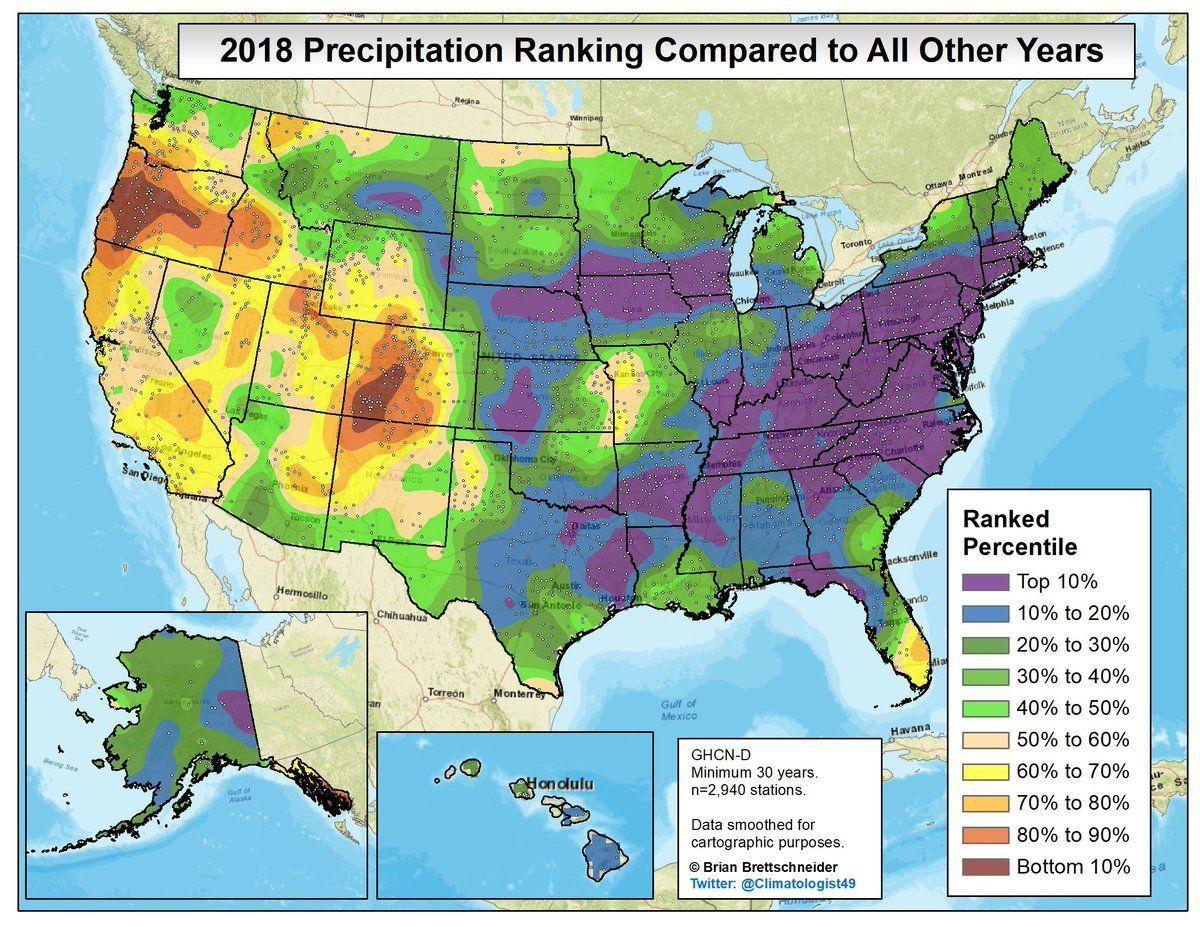Which color depict the bottom 10% precipitation ranking, red, orange or yellow?
Answer the question with a short phrase. red Which color depicts the top 10%  precipitation ranking, blue , green or purple? purple How many regions can Honolulu be divided based on the precipitation ranking? 2 How many ranks are given within the ranked percentile? 10 What are the range of values in the ranked percentile ? Bottom 10% to Top 10% How many regions can Alaska be divided based on the precipitation ranking? 3 Which colors represent the precipitation ranking of Honolulu? green and blue 